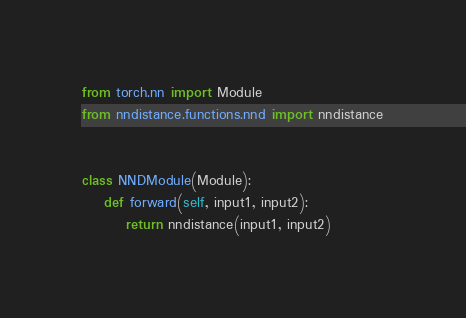Convert code to text. <code><loc_0><loc_0><loc_500><loc_500><_Python_>from torch.nn import Module
from nndistance.functions.nnd import nndistance


class NNDModule(Module):
    def forward(self, input1, input2):
        return nndistance(input1, input2)
</code> 